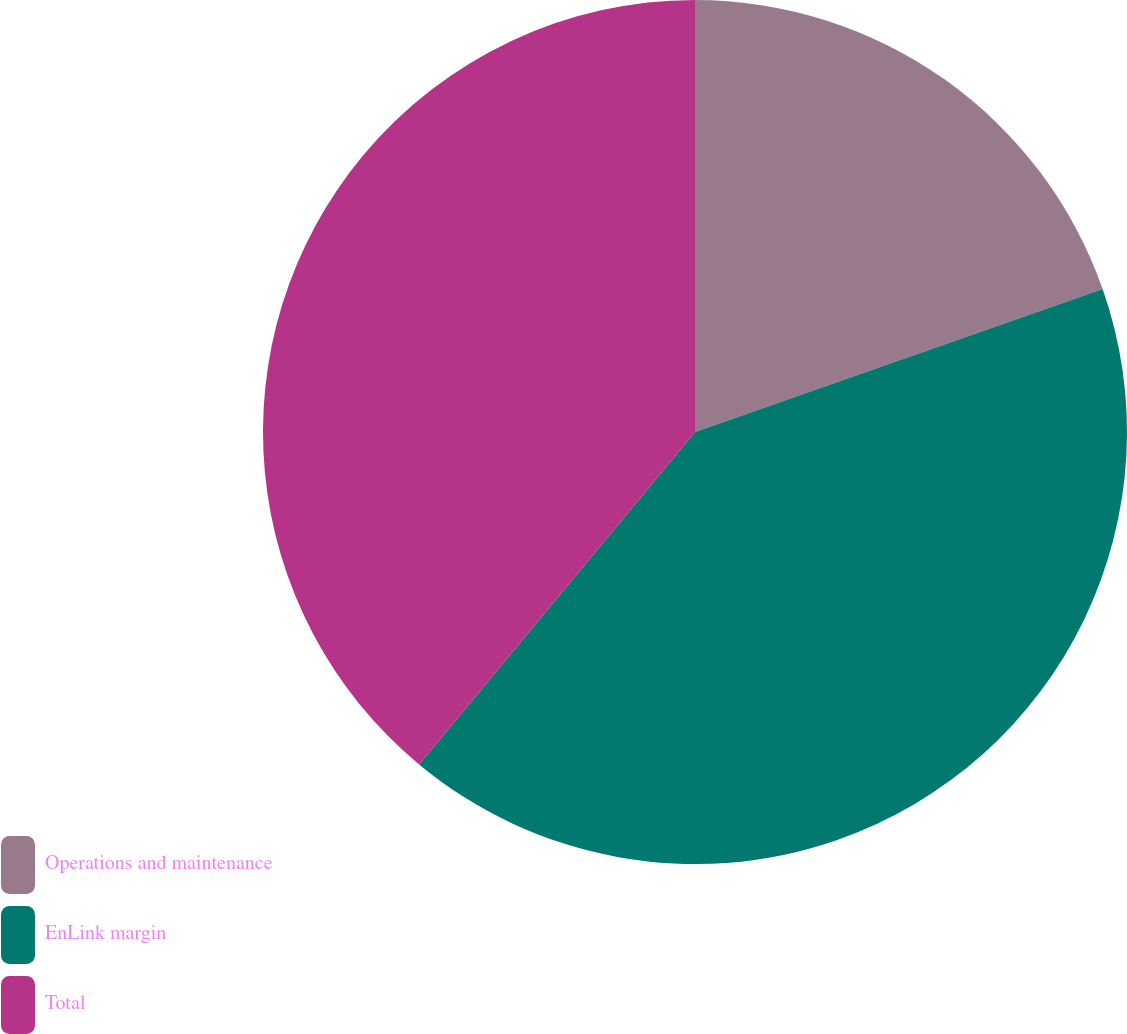Convert chart to OTSL. <chart><loc_0><loc_0><loc_500><loc_500><pie_chart><fcel>Operations and maintenance<fcel>EnLink margin<fcel>Total<nl><fcel>19.63%<fcel>41.39%<fcel>38.97%<nl></chart> 